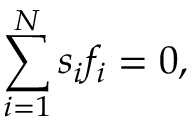Convert formula to latex. <formula><loc_0><loc_0><loc_500><loc_500>\sum _ { i = 1 } ^ { N } s _ { i } f _ { i } = 0 ,</formula> 